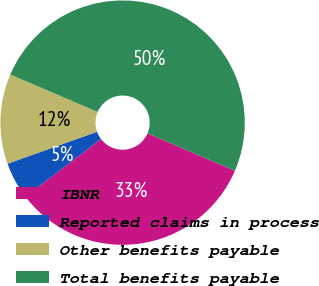Convert chart to OTSL. <chart><loc_0><loc_0><loc_500><loc_500><pie_chart><fcel>IBNR<fcel>Reported claims in process<fcel>Other benefits payable<fcel>Total benefits payable<nl><fcel>33.2%<fcel>4.9%<fcel>11.9%<fcel>50.0%<nl></chart> 